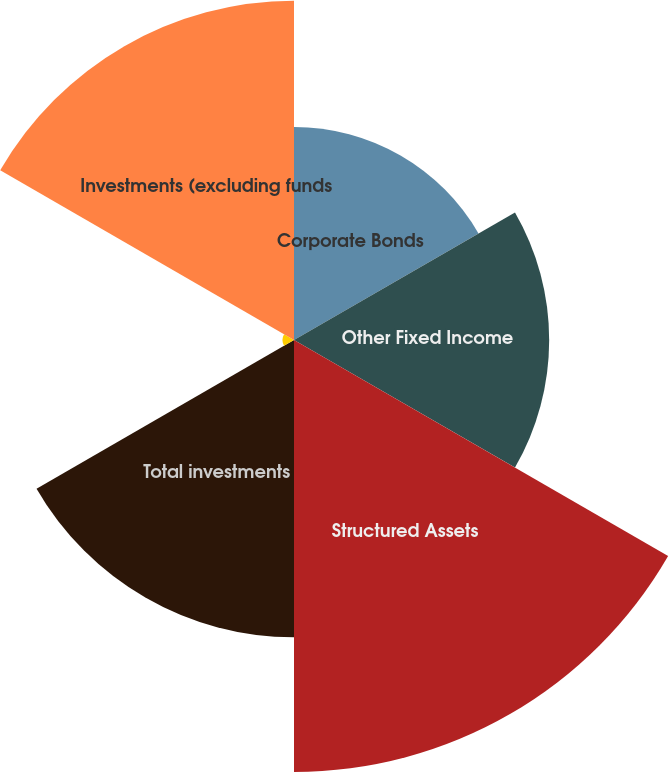<chart> <loc_0><loc_0><loc_500><loc_500><pie_chart><fcel>Corporate Bonds<fcel>Other Fixed Income<fcel>Structured Assets<fcel>Total investments<fcel>Funds for retiree health<fcel>Investments (excluding funds<nl><fcel>13.76%<fcel>16.48%<fcel>27.9%<fcel>19.2%<fcel>0.74%<fcel>21.91%<nl></chart> 